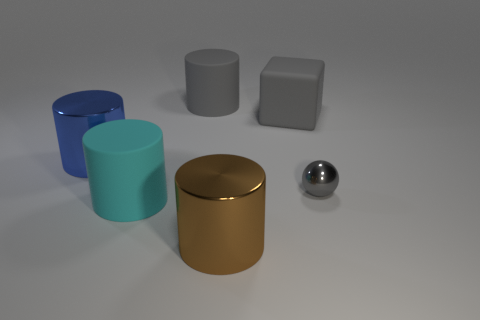Subtract 1 cylinders. How many cylinders are left? 3 Add 1 big brown shiny cylinders. How many objects exist? 7 Subtract all cylinders. How many objects are left? 2 Subtract all cylinders. Subtract all tiny objects. How many objects are left? 1 Add 5 tiny things. How many tiny things are left? 6 Add 5 balls. How many balls exist? 6 Subtract 0 yellow blocks. How many objects are left? 6 